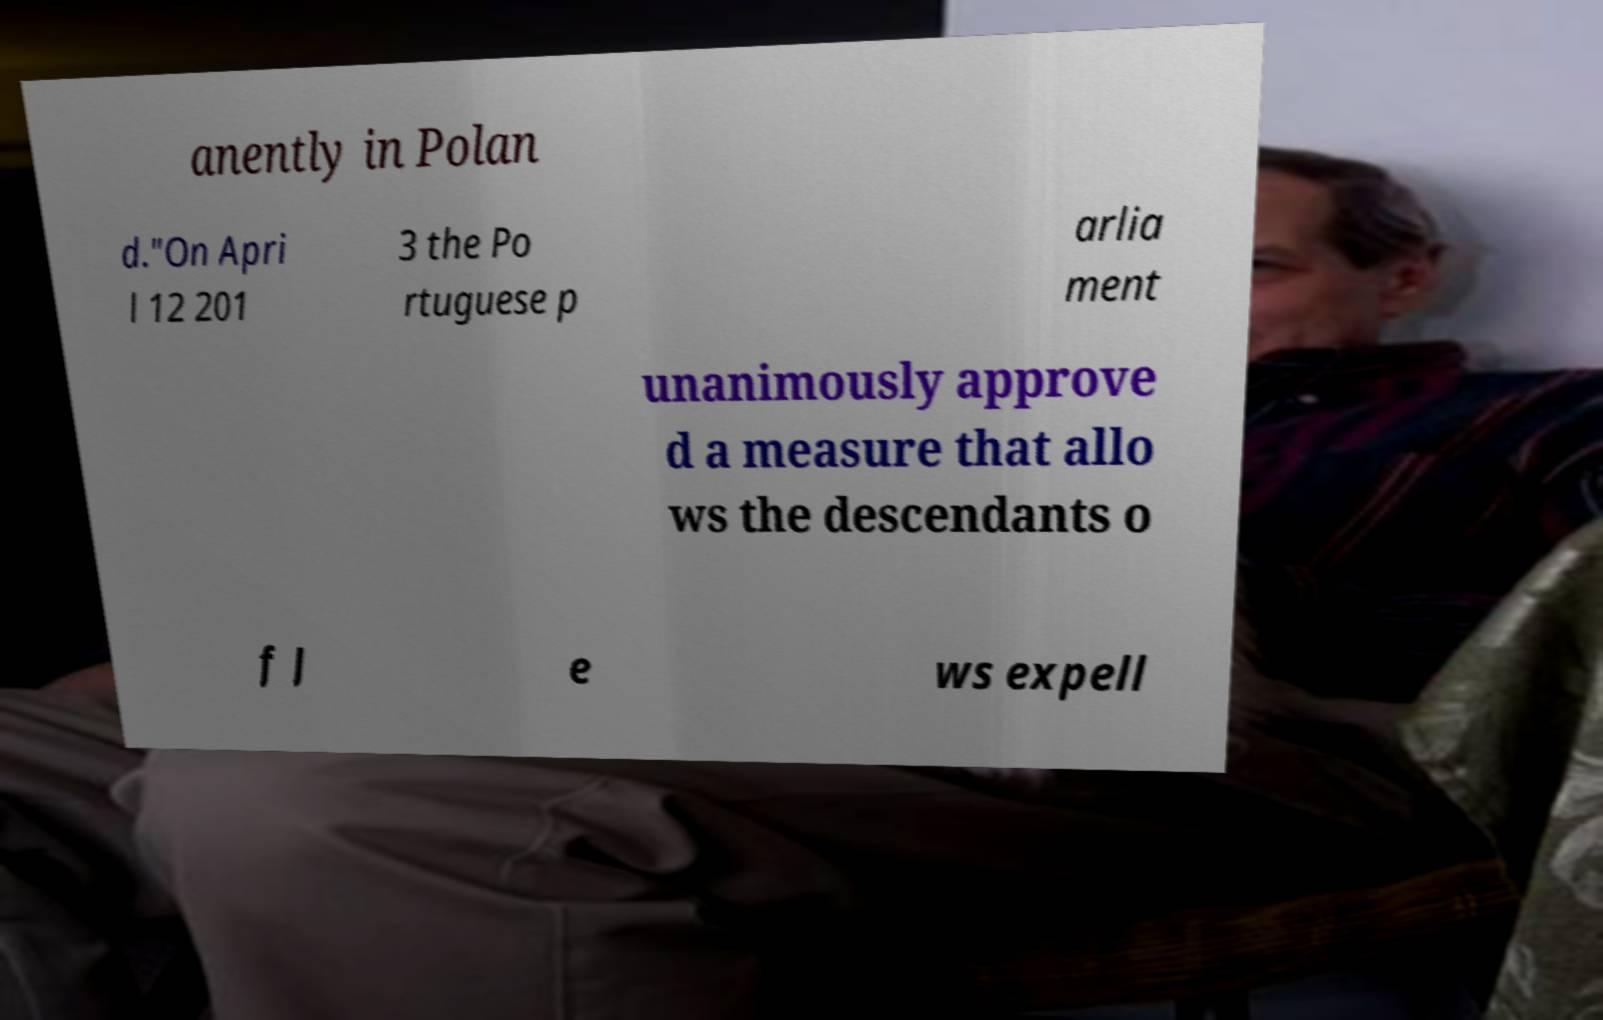Can you accurately transcribe the text from the provided image for me? anently in Polan d."On Apri l 12 201 3 the Po rtuguese p arlia ment unanimously approve d a measure that allo ws the descendants o f J e ws expell 